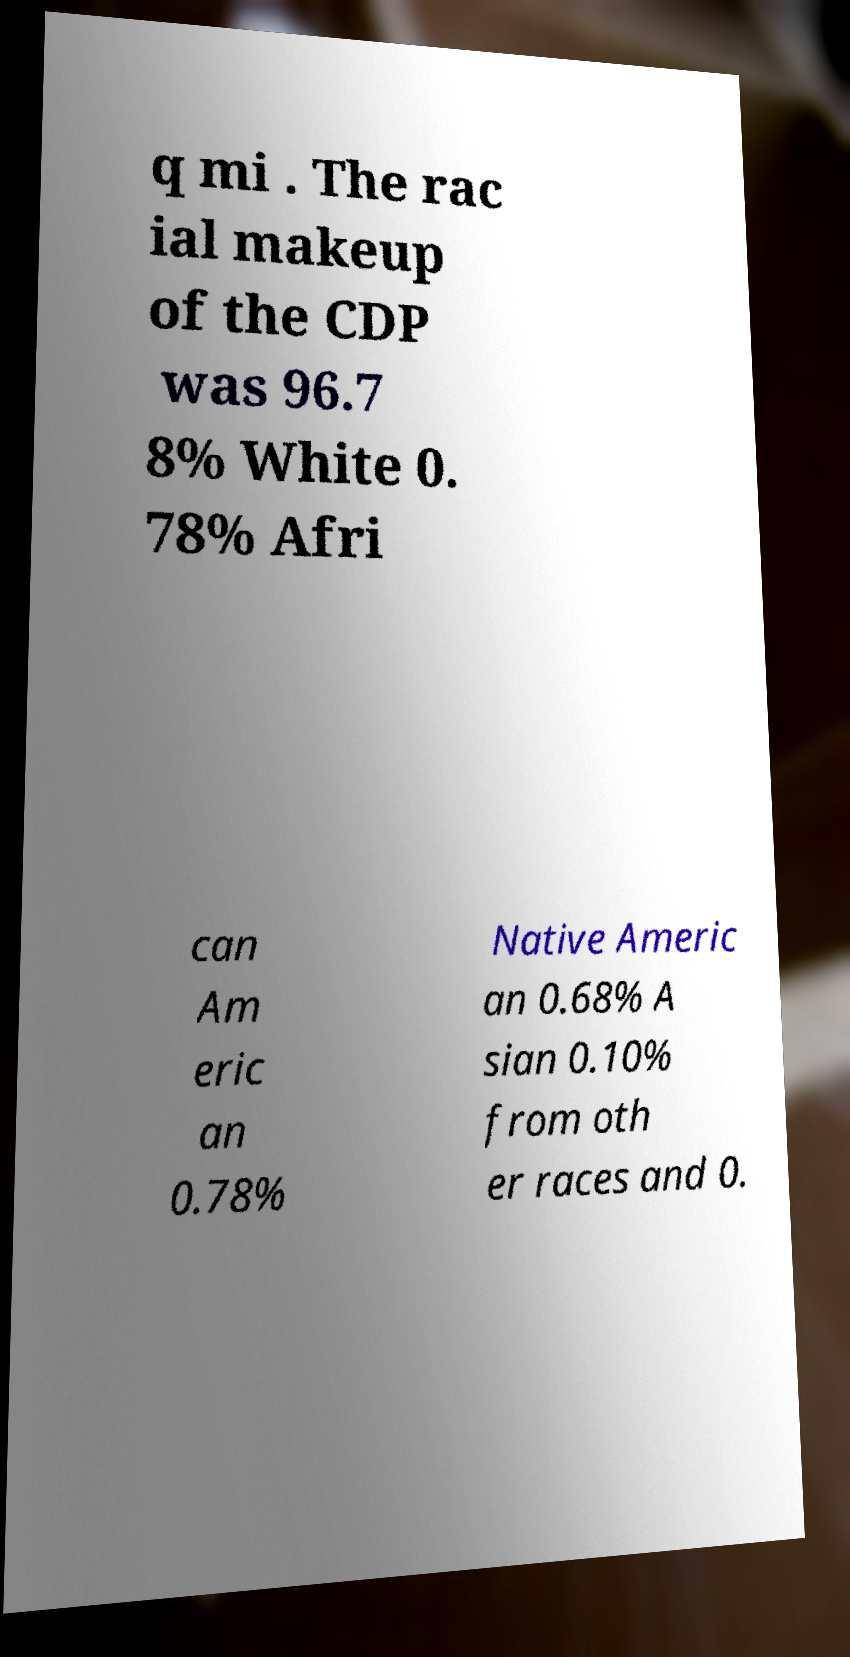Could you assist in decoding the text presented in this image and type it out clearly? q mi . The rac ial makeup of the CDP was 96.7 8% White 0. 78% Afri can Am eric an 0.78% Native Americ an 0.68% A sian 0.10% from oth er races and 0. 